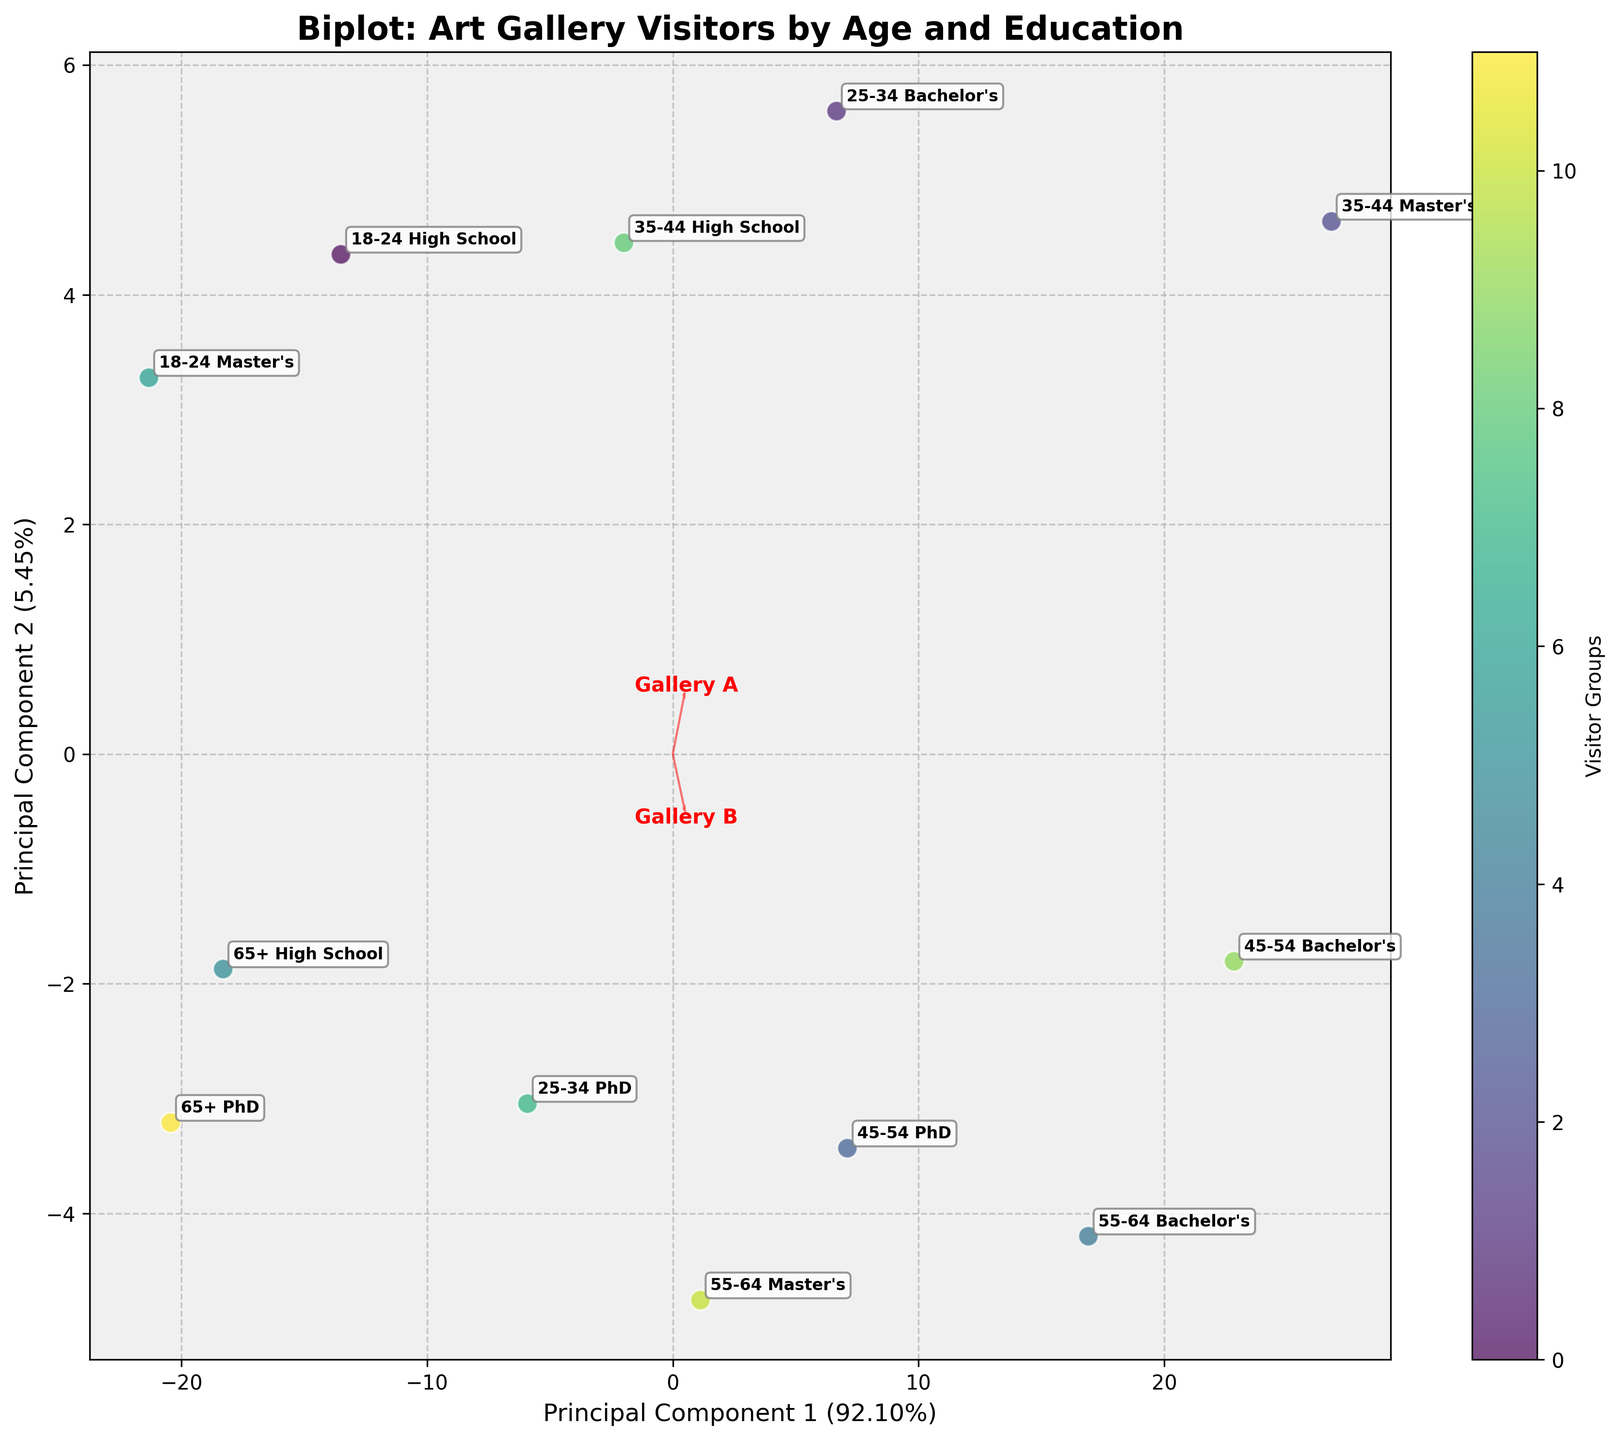What is the title of the figure? The title can be found at the top of the figure in bold and larger font size.
Answer: Biplot: Art Gallery Visitors by Age and Education How many principal components are shown in the biplot? The figure has two axes labeled "Principal Component 1" and "Principal Component 2," indicating the number of principal components displayed.
Answer: Two Which age and education group appears closest to the origin? Look for the data point closest to both the x-axis and y-axis origin (0,0).
Answer: 18-24 High School Which gallery seems to have the highest loading on Principal Component 1? Observe the direction and length of the feature vectors. The one extending the furthest along the x-axis for Principal Component 1 has the highest loading.
Answer: Gallery D What percentage of variance is explained by Principal Component 1? This information is given in the label of the x-axis in parentheses, showing the percentage.
Answer: Approximately 56% Which two groups are most closely clustered together? Check for groups that are positioned very near each other in the biplot.
Answer: 25-34 PhD and 45-54 Bachelor's What is the color used for the youngest age group with Master's education? Identify the color from the scatterplot legend corresponding to the "18-24 Master's" group.
Answer: Greenish-yellow Which gallery has the most influence on Principal Component 2? The feature vector extending the furthest along the y-axis indicates higher influence on Principal Component 2.
Answer: Gallery C Between the groups "35-44 High School" and "55-64 Bachelor's", which is positioned higher on Principal Component 2? Compare the y-coordinates of the two specified data points to see which one is higher.
Answer: 55-64 Bachelor's Do older age groups with lower education levels tend to cluster together or spread out? Observe the positions of older age groups with lower education levels (e.g., 65+ High School) and determine if they form a cluster or are distributed.
Answer: Cluster together 